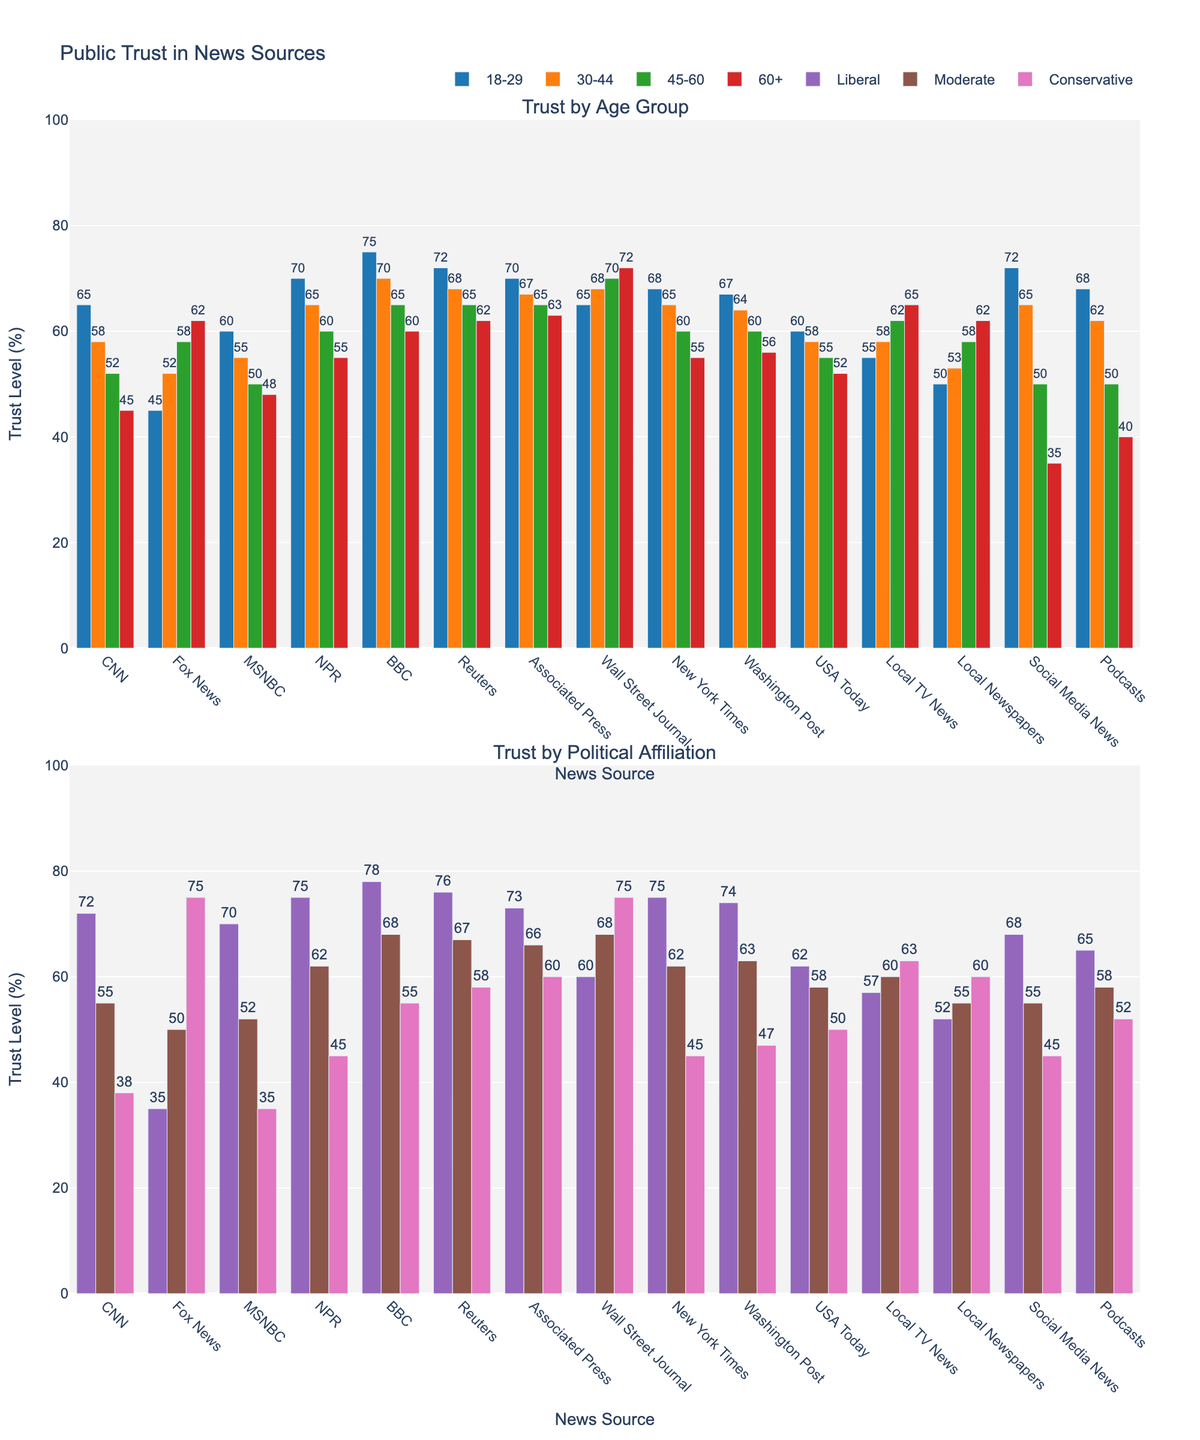Which news source has the highest trust level among the 18-29 age group? Look at the bar representing the 18-29 age group and find the tallest one. This is for BBC.
Answer: BBC Which age group shows the least trust in Social Media News? Compare the heights of the bars for "Social Media News" across all age groups. The shortest bar is for the 60+ group.
Answer: 60+ How does trust in the Wall Street Journal vary between ages 45-60 and 60+? Observe the bars corresponding to "Wall Street Journal" for the 45-60 and 60+ age groups. The figures are 70 (45-60) and 72 (60+).
Answer: Trust is slightly higher for 60+ What is the average trust level in NPR across all political groups? Add the trust levels for NPR across the political groups (75+62+45) and divide by 3. (75+62+45)/3 = 60.67.
Answer: 60.67 Which news source shows the largest difference in trust level between conservatives and liberals? Compare the absolute differences in trust levels between liberals and conservatives for each news source. Fox News shows the largest difference of 40 percent (75-35).
Answer: Fox News Is the trust level for Local TV News higher among 30-44 or 60+ age groups? Compare the heights of the bars for "Local TV News" between the 30-44 and 60+ groups. The figures are 58 (30-44) and 65 (60+).
Answer: 60+ Which demographic group shows the highest trust in Reuters? Find the tallest bar for Reuters; it belongs to the Liberal group.
Answer: Liberal What is the difference in trust level between the most trusted and least trusted news source among the 45-60 age group? Identify the tallest (Wall Street Journal: 70) and shortest (Social Media News: 50) bars in the 45-60 group. Subtract the smallest from the largest (70-50).
Answer: 20 How does trust in New York Times compare between moderates and conservatives? Compare the heights of the bars for "New York Times" in both the moderate and conservative groups. The figures are 62 (moderates) and 45 (conservatives).
Answer: Higher among moderates Identify the news source with the least variability in trust levels among the political groups (Liberal, Moderate, Conservative). Calculate the range (max-min) of trust levels for each news source across political groups and find the smallest range. Reuters shows the smallest variability with ranges 76-58=18.
Answer: Reuters 